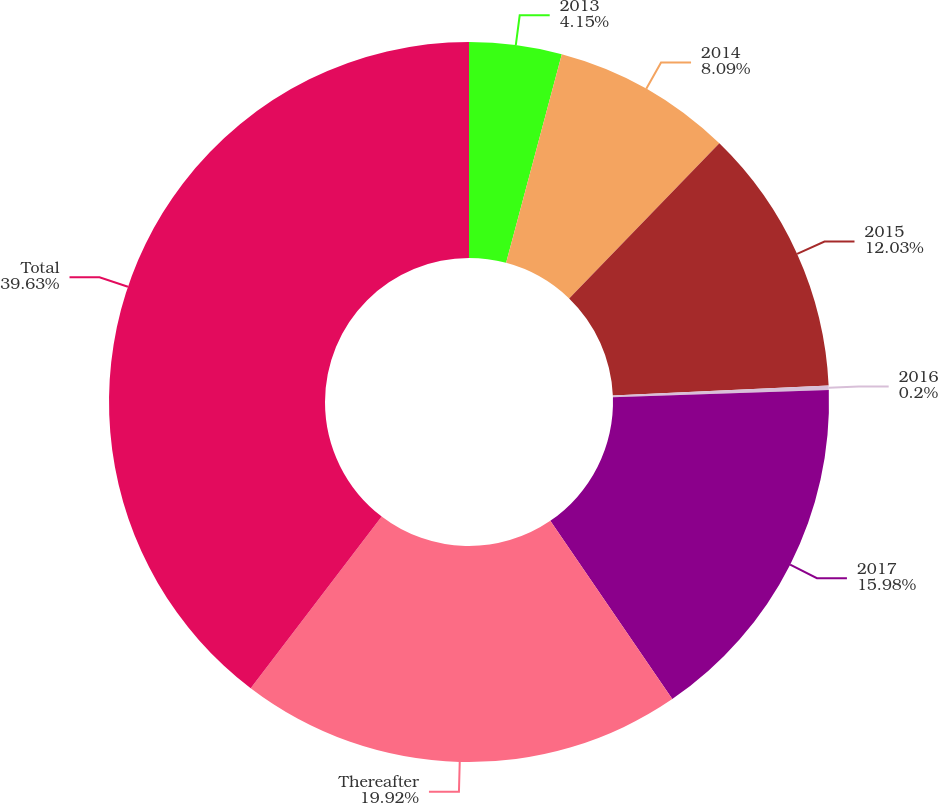Convert chart to OTSL. <chart><loc_0><loc_0><loc_500><loc_500><pie_chart><fcel>2013<fcel>2014<fcel>2015<fcel>2016<fcel>2017<fcel>Thereafter<fcel>Total<nl><fcel>4.15%<fcel>8.09%<fcel>12.03%<fcel>0.2%<fcel>15.98%<fcel>19.92%<fcel>39.63%<nl></chart> 